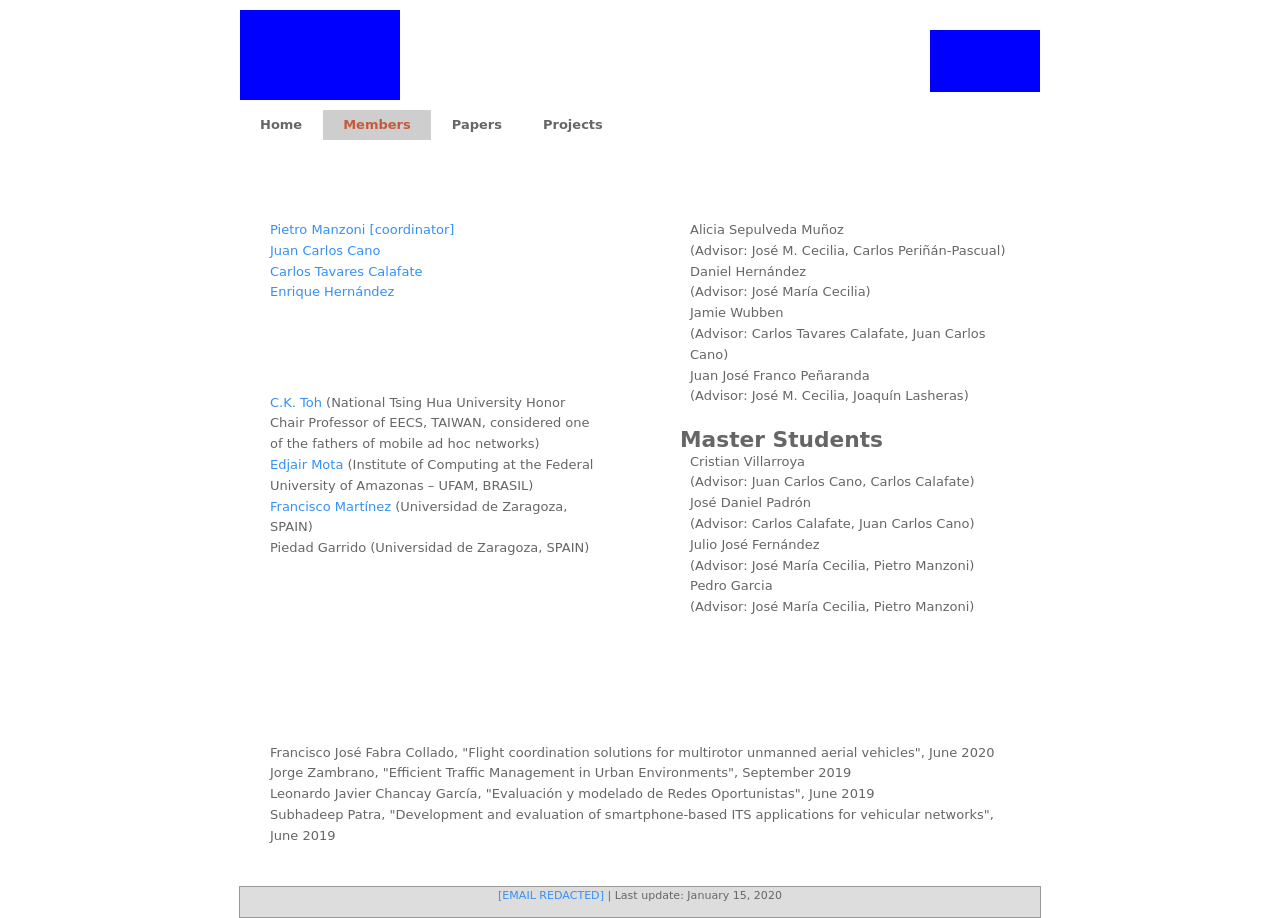I see a section called 'Collaborators/Advisors'; how important is international collaboration in their projects? International collaboration is crucial, bringing diverse perspectives and expertise to the research projects. It enhances the quality and scope of the research, often leading to innovations that may not be possible in a single-country context. The presence of international collaborators like those from Taiwan and Brazil highlights the global network and the broad impact of their research activities. 